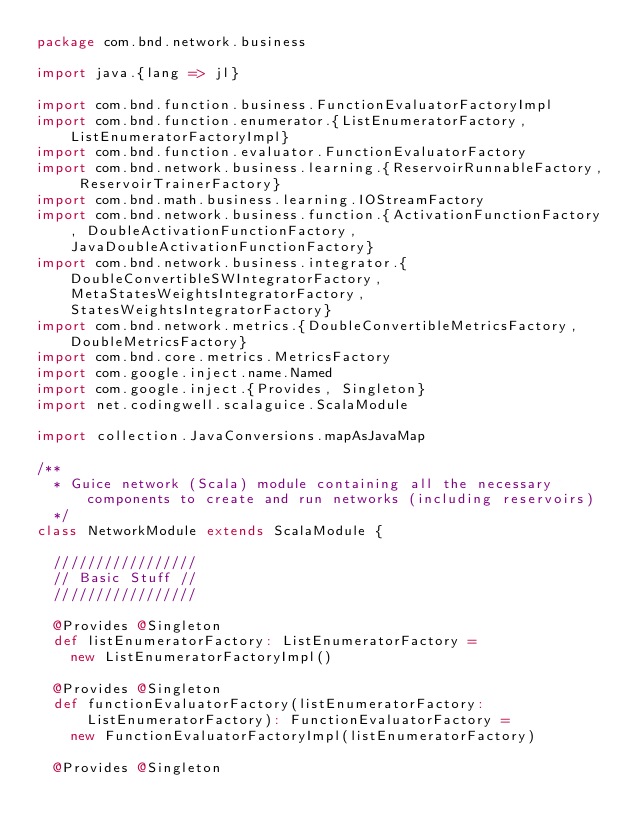<code> <loc_0><loc_0><loc_500><loc_500><_Scala_>package com.bnd.network.business

import java.{lang => jl}

import com.bnd.function.business.FunctionEvaluatorFactoryImpl
import com.bnd.function.enumerator.{ListEnumeratorFactory, ListEnumeratorFactoryImpl}
import com.bnd.function.evaluator.FunctionEvaluatorFactory
import com.bnd.network.business.learning.{ReservoirRunnableFactory, ReservoirTrainerFactory}
import com.bnd.math.business.learning.IOStreamFactory
import com.bnd.network.business.function.{ActivationFunctionFactory, DoubleActivationFunctionFactory, JavaDoubleActivationFunctionFactory}
import com.bnd.network.business.integrator.{DoubleConvertibleSWIntegratorFactory, MetaStatesWeightsIntegratorFactory, StatesWeightsIntegratorFactory}
import com.bnd.network.metrics.{DoubleConvertibleMetricsFactory, DoubleMetricsFactory}
import com.bnd.core.metrics.MetricsFactory
import com.google.inject.name.Named
import com.google.inject.{Provides, Singleton}
import net.codingwell.scalaguice.ScalaModule

import collection.JavaConversions.mapAsJavaMap

/**
  * Guice network (Scala) module containing all the necessary components to create and run networks (including reservoirs)
  */
class NetworkModule extends ScalaModule {

  /////////////////
  // Basic Stuff //
  /////////////////

  @Provides @Singleton
  def listEnumeratorFactory: ListEnumeratorFactory =
    new ListEnumeratorFactoryImpl()

  @Provides @Singleton
  def functionEvaluatorFactory(listEnumeratorFactory: ListEnumeratorFactory): FunctionEvaluatorFactory =
    new FunctionEvaluatorFactoryImpl(listEnumeratorFactory)

  @Provides @Singleton</code> 